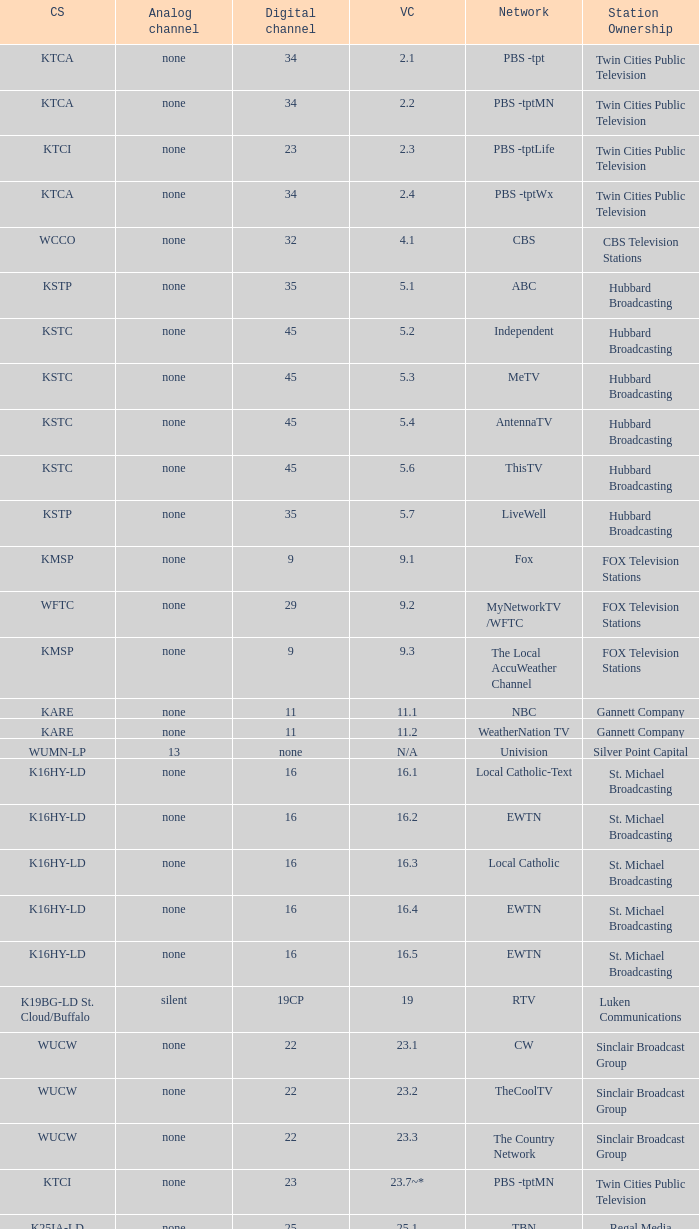Virtual channel of 16.5 has what call sign? K16HY-LD. 